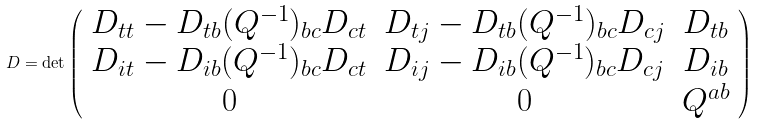<formula> <loc_0><loc_0><loc_500><loc_500>D = \det \left ( \begin{array} { c c c } D _ { t t } - D _ { t b } ( Q ^ { - 1 } ) _ { b c } D _ { c t } & D _ { t j } - D _ { t b } ( Q ^ { - 1 } ) _ { b c } D _ { c j } & D _ { t b } \\ D _ { i t } - D _ { i b } ( Q ^ { - 1 } ) _ { b c } D _ { c t } & D _ { i j } - D _ { i b } ( Q ^ { - 1 } ) _ { b c } D _ { c j } & D _ { i b } \\ 0 & 0 & Q ^ { a b } \\ \end{array} \right )</formula> 